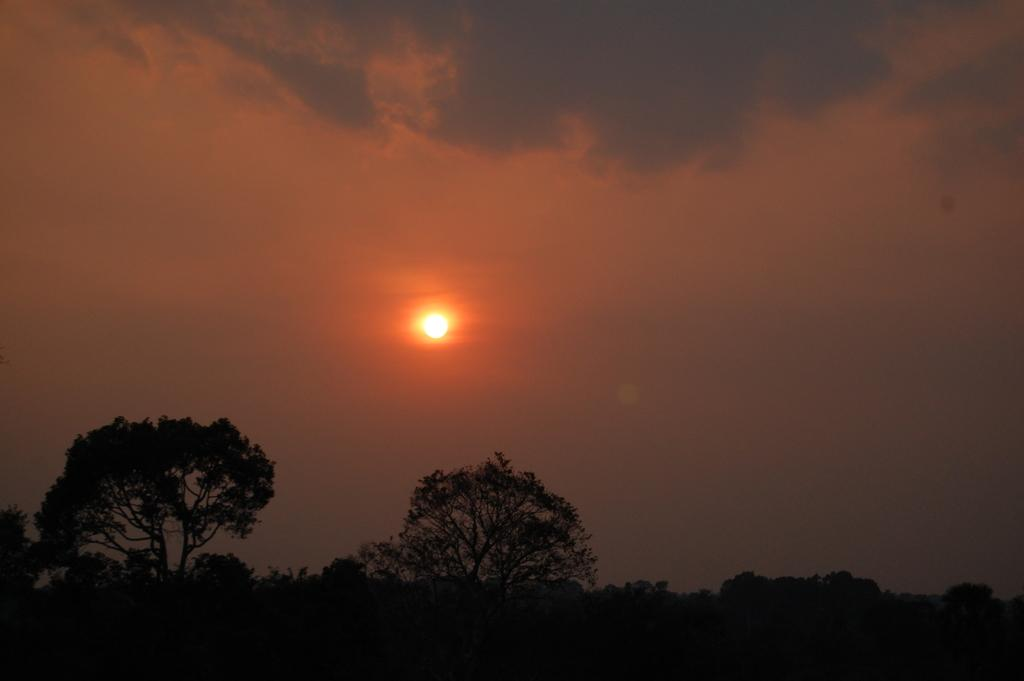What celestial body can be seen in the image? The sun is visible in the image. What else is visible in the sky in the image? The sky is visible in the image, along with clouds. What type of vegetation is present at the bottom of the image? Trees, plants, and grass are present at the bottom of the image. How many boats can be seen sailing in the grass at the bottom of the image? There are no boats present in the image; it features the sun, sky, clouds, trees, plants, and grass. Is there a tiger hiding among the trees at the bottom of the image? There is no tiger present in the image; it only features trees, plants, and grass. 